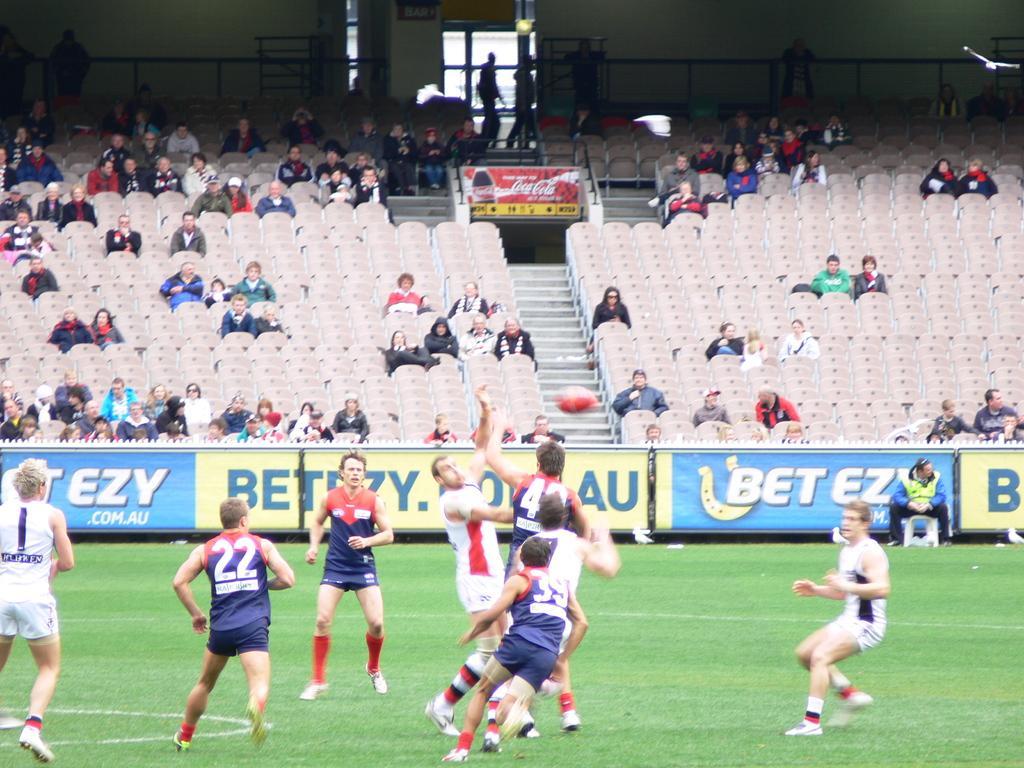Could you give a brief overview of what you see in this image? Here people are walking in the ground, where people are sitting on the chair, here there is bottle, this is ground. 